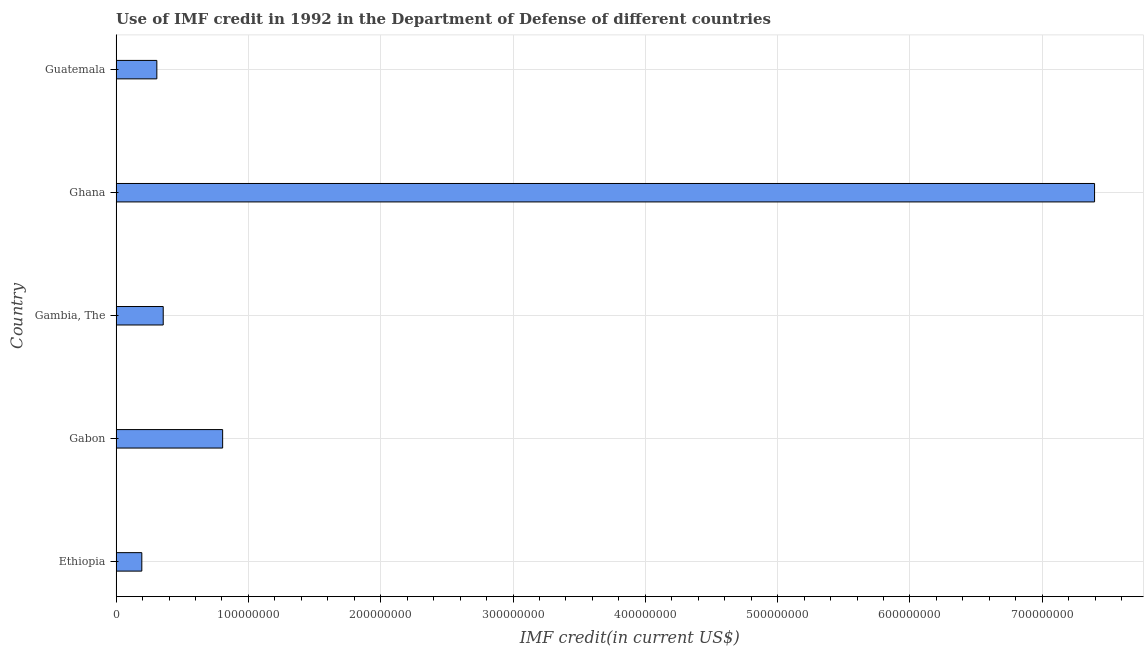What is the title of the graph?
Give a very brief answer. Use of IMF credit in 1992 in the Department of Defense of different countries. What is the label or title of the X-axis?
Provide a short and direct response. IMF credit(in current US$). What is the label or title of the Y-axis?
Your response must be concise. Country. What is the use of imf credit in dod in Gabon?
Offer a terse response. 8.05e+07. Across all countries, what is the maximum use of imf credit in dod?
Offer a very short reply. 7.40e+08. Across all countries, what is the minimum use of imf credit in dod?
Provide a short and direct response. 1.94e+07. In which country was the use of imf credit in dod maximum?
Your response must be concise. Ghana. In which country was the use of imf credit in dod minimum?
Provide a short and direct response. Ethiopia. What is the sum of the use of imf credit in dod?
Your answer should be very brief. 9.06e+08. What is the difference between the use of imf credit in dod in Ethiopia and Ghana?
Offer a terse response. -7.20e+08. What is the average use of imf credit in dod per country?
Keep it short and to the point. 1.81e+08. What is the median use of imf credit in dod?
Offer a very short reply. 3.56e+07. In how many countries, is the use of imf credit in dod greater than 460000000 US$?
Your response must be concise. 1. What is the ratio of the use of imf credit in dod in Gambia, The to that in Guatemala?
Keep it short and to the point. 1.16. What is the difference between the highest and the second highest use of imf credit in dod?
Offer a very short reply. 6.59e+08. Is the sum of the use of imf credit in dod in Gambia, The and Guatemala greater than the maximum use of imf credit in dod across all countries?
Keep it short and to the point. No. What is the difference between the highest and the lowest use of imf credit in dod?
Your answer should be compact. 7.20e+08. In how many countries, is the use of imf credit in dod greater than the average use of imf credit in dod taken over all countries?
Ensure brevity in your answer.  1. What is the difference between two consecutive major ticks on the X-axis?
Your response must be concise. 1.00e+08. Are the values on the major ticks of X-axis written in scientific E-notation?
Ensure brevity in your answer.  No. What is the IMF credit(in current US$) of Ethiopia?
Provide a short and direct response. 1.94e+07. What is the IMF credit(in current US$) in Gabon?
Provide a succinct answer. 8.05e+07. What is the IMF credit(in current US$) in Gambia, The?
Your answer should be very brief. 3.56e+07. What is the IMF credit(in current US$) in Ghana?
Your answer should be compact. 7.40e+08. What is the IMF credit(in current US$) of Guatemala?
Offer a very short reply. 3.08e+07. What is the difference between the IMF credit(in current US$) in Ethiopia and Gabon?
Provide a succinct answer. -6.11e+07. What is the difference between the IMF credit(in current US$) in Ethiopia and Gambia, The?
Make the answer very short. -1.62e+07. What is the difference between the IMF credit(in current US$) in Ethiopia and Ghana?
Keep it short and to the point. -7.20e+08. What is the difference between the IMF credit(in current US$) in Ethiopia and Guatemala?
Offer a terse response. -1.14e+07. What is the difference between the IMF credit(in current US$) in Gabon and Gambia, The?
Offer a very short reply. 4.49e+07. What is the difference between the IMF credit(in current US$) in Gabon and Ghana?
Give a very brief answer. -6.59e+08. What is the difference between the IMF credit(in current US$) in Gabon and Guatemala?
Make the answer very short. 4.97e+07. What is the difference between the IMF credit(in current US$) in Gambia, The and Ghana?
Offer a terse response. -7.04e+08. What is the difference between the IMF credit(in current US$) in Gambia, The and Guatemala?
Your answer should be very brief. 4.82e+06. What is the difference between the IMF credit(in current US$) in Ghana and Guatemala?
Provide a short and direct response. 7.09e+08. What is the ratio of the IMF credit(in current US$) in Ethiopia to that in Gabon?
Give a very brief answer. 0.24. What is the ratio of the IMF credit(in current US$) in Ethiopia to that in Gambia, The?
Give a very brief answer. 0.55. What is the ratio of the IMF credit(in current US$) in Ethiopia to that in Ghana?
Your answer should be very brief. 0.03. What is the ratio of the IMF credit(in current US$) in Ethiopia to that in Guatemala?
Your answer should be compact. 0.63. What is the ratio of the IMF credit(in current US$) in Gabon to that in Gambia, The?
Offer a very short reply. 2.26. What is the ratio of the IMF credit(in current US$) in Gabon to that in Ghana?
Give a very brief answer. 0.11. What is the ratio of the IMF credit(in current US$) in Gabon to that in Guatemala?
Your answer should be compact. 2.62. What is the ratio of the IMF credit(in current US$) in Gambia, The to that in Ghana?
Keep it short and to the point. 0.05. What is the ratio of the IMF credit(in current US$) in Gambia, The to that in Guatemala?
Your answer should be very brief. 1.16. What is the ratio of the IMF credit(in current US$) in Ghana to that in Guatemala?
Your answer should be very brief. 24.03. 